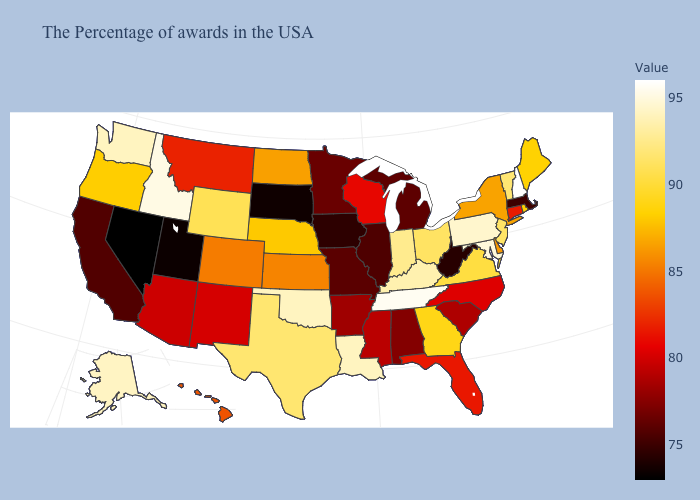Which states hav the highest value in the MidWest?
Give a very brief answer. Indiana. Does Utah have a lower value than Florida?
Answer briefly. Yes. Which states have the highest value in the USA?
Be succinct. New Hampshire. Is the legend a continuous bar?
Keep it brief. Yes. 